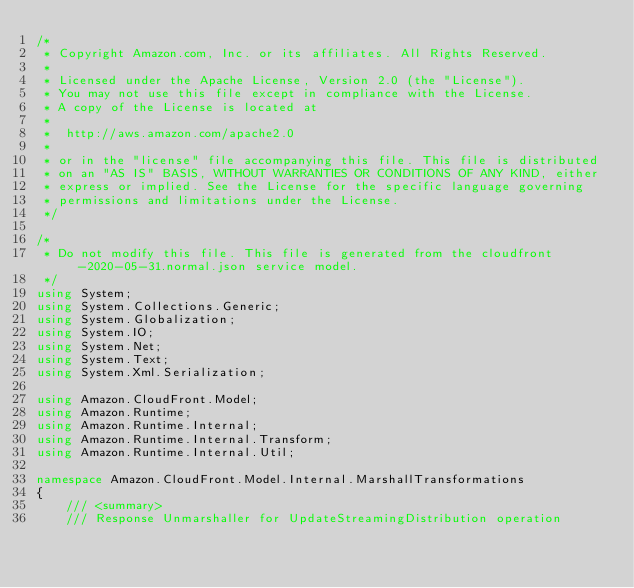<code> <loc_0><loc_0><loc_500><loc_500><_C#_>/*
 * Copyright Amazon.com, Inc. or its affiliates. All Rights Reserved.
 * 
 * Licensed under the Apache License, Version 2.0 (the "License").
 * You may not use this file except in compliance with the License.
 * A copy of the License is located at
 * 
 *  http://aws.amazon.com/apache2.0
 * 
 * or in the "license" file accompanying this file. This file is distributed
 * on an "AS IS" BASIS, WITHOUT WARRANTIES OR CONDITIONS OF ANY KIND, either
 * express or implied. See the License for the specific language governing
 * permissions and limitations under the License.
 */

/*
 * Do not modify this file. This file is generated from the cloudfront-2020-05-31.normal.json service model.
 */
using System;
using System.Collections.Generic;
using System.Globalization;
using System.IO;
using System.Net;
using System.Text;
using System.Xml.Serialization;

using Amazon.CloudFront.Model;
using Amazon.Runtime;
using Amazon.Runtime.Internal;
using Amazon.Runtime.Internal.Transform;
using Amazon.Runtime.Internal.Util;

namespace Amazon.CloudFront.Model.Internal.MarshallTransformations
{
    /// <summary>
    /// Response Unmarshaller for UpdateStreamingDistribution operation</code> 